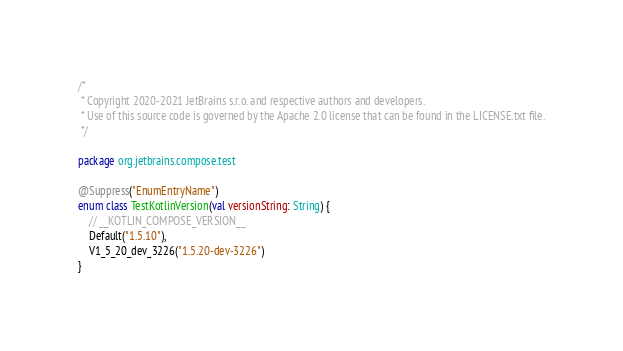<code> <loc_0><loc_0><loc_500><loc_500><_Kotlin_>/*
 * Copyright 2020-2021 JetBrains s.r.o. and respective authors and developers.
 * Use of this source code is governed by the Apache 2.0 license that can be found in the LICENSE.txt file.
 */

package org.jetbrains.compose.test

@Suppress("EnumEntryName")
enum class TestKotlinVersion(val versionString: String) {
    // __KOTLIN_COMPOSE_VERSION__
    Default("1.5.10"),
    V1_5_20_dev_3226("1.5.20-dev-3226")
}</code> 